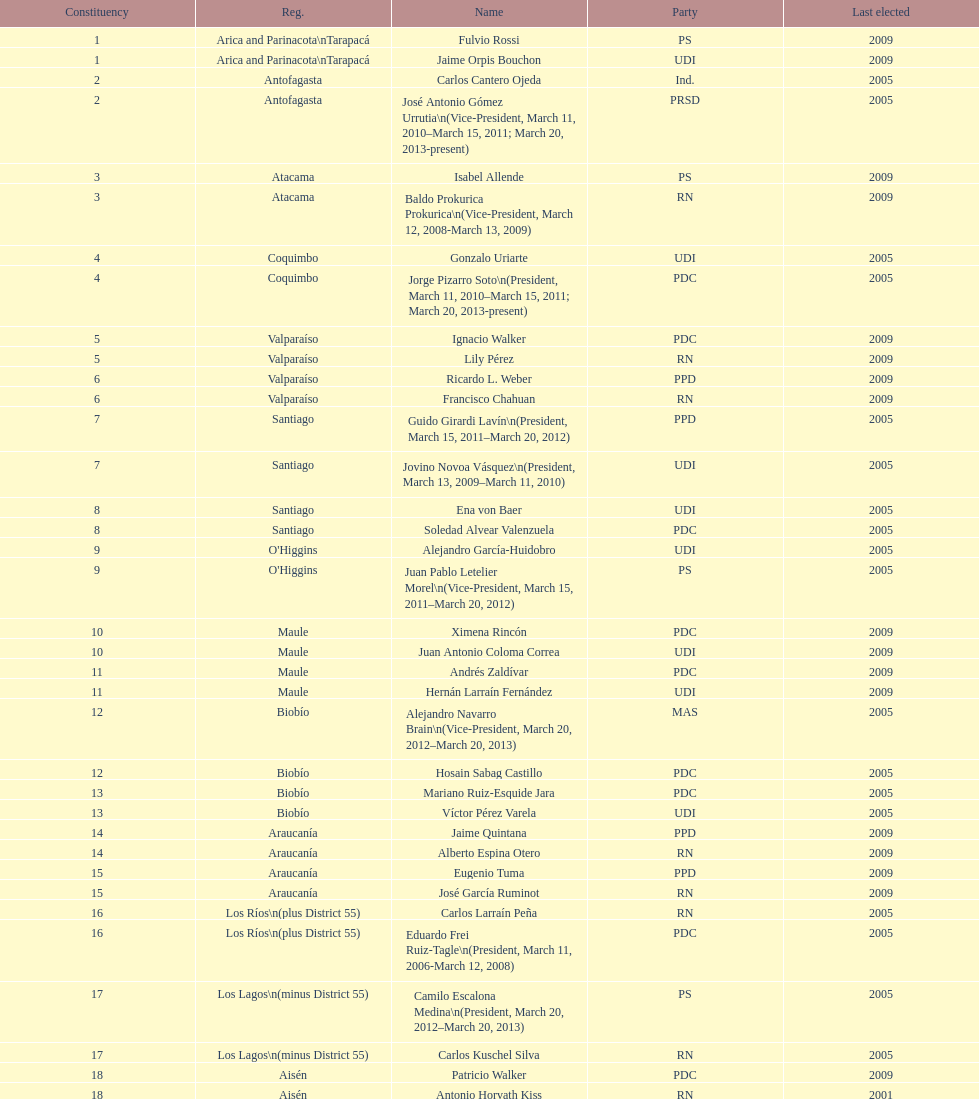What is the total number of constituencies listed in the table? 19. 